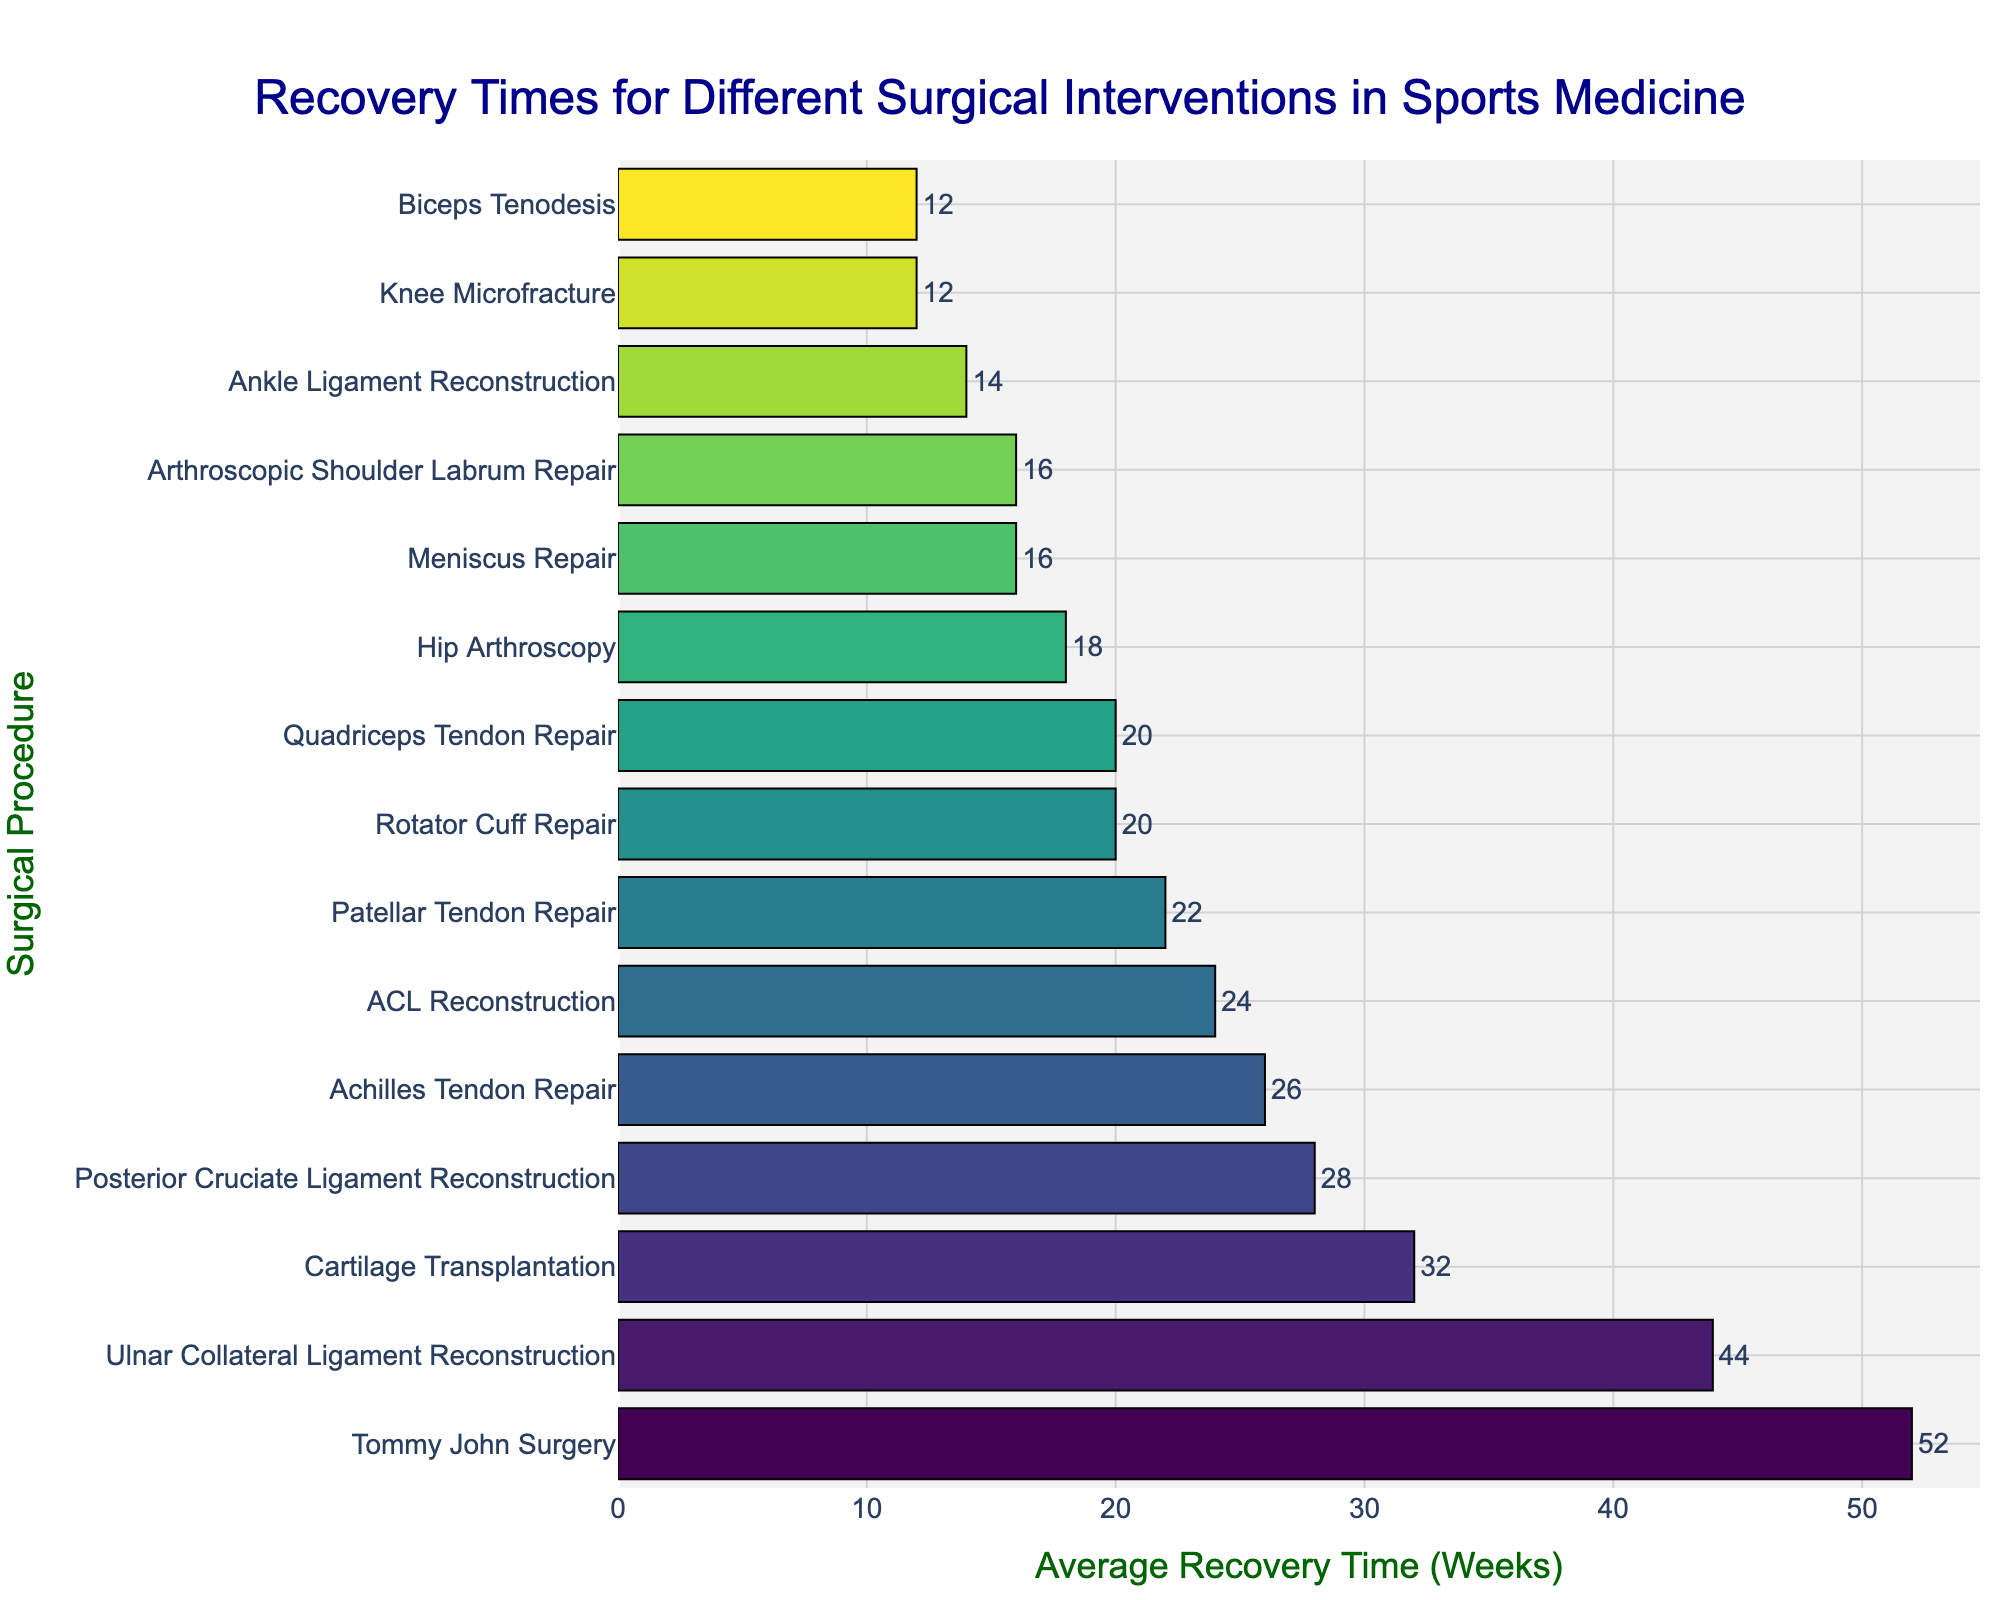Which surgical procedure has the longest average recovery time? The bar with the longest length will represent the surgical procedure with the longest average recovery time.
Answer: Tommy John Surgery Which surgical procedure has the shortest average recovery time? The bar with the shortest length will represent the surgical procedure with the shortest average recovery time.
Answer: Knee Microfracture and Biceps Tenodesis How much longer is the recovery time for Tommy John Surgery compared to ACL Reconstruction? Identify the lengths of the bars for Tommy John Surgery and ACL Reconstruction and subtract the shorter from the longer one: 52 weeks - 24 weeks = 28 weeks.
Answer: 28 weeks What is the median recovery time for these surgical procedures? Organize all recovery times in ascending order (12, 12, 14, 16, 16, 18, 20, 20, 22, 24, 26, 28, 32, 44, 52). The median is the middle value, which is 20.
Answer: 20 weeks Which surgical procedures have the same recovery time? Identify bars with the same lengths: Meniscus Repair and Arthroscopic Shoulder Labrum Repair (16 weeks), Rotator Cuff Repair and Quadriceps Tendon Repair (20 weeks).
Answer: Meniscus Repair and Arthroscopic Shoulder Labrum Repair & Rotator Cuff Repair and Quadriceps Tendon Repair How many procedures have a recovery time of 20 weeks or more? Count all the bars that are equal to or longer than the 20-week mark: ACL Reconstruction, Rotator Cuff Repair, Tommy John Surgery, Achilles Tendon Repair, Patellar Tendon Repair, Posterior Cruciate Ligament Reconstruction, Cartilage Transplantation, Ulnar Collateral Ligament Reconstruction, Quadriceps Tendon Repair. Total is 9.
Answer: 9 Is the difference in recovery times between Rotator Cuff Repair and Meniscus Repair greater or less than 10 weeks? The difference in the lengths of their bars is 20 weeks - 16 weeks = 4 weeks, which is less than 10 weeks.
Answer: Less than 10 weeks Which procedure has a recovery time exactly half of Tommy John Surgery? Tommy John Surgery has a recovery time of 52 weeks. Exactly half would be 52 / 2 = 26 weeks, which corresponds to Achilles Tendon Repair.
Answer: Achilles Tendon Repair How much shorter is the recovery time for Ankle Ligament Reconstruction compared to Cartilage Transplantation? Identify the lengths of the bars for Ankle Ligament Reconstruction and Cartilage Transplantation and subtract the shorter from the longer one: 32 weeks - 14 weeks = 18 weeks.
Answer: 18 weeks Which procedures have a recovery time greater than 30 weeks? Identify bars longer than 30 weeks: Cartilage Transplantation (32 weeks), Ulnar Collateral Ligament Reconstruction (44 weeks), Tommy John Surgery (52 weeks).
Answer: Cartilage Transplantation, Ulnar Collateral Ligament Reconstruction, Tommy John Surgery 